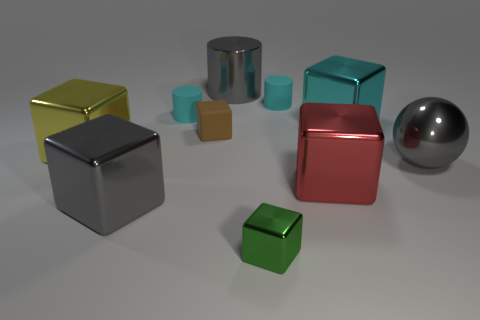Subtract all brown blocks. How many blocks are left? 5 Subtract all large gray cubes. How many cubes are left? 5 Subtract all cyan blocks. Subtract all purple balls. How many blocks are left? 5 Subtract all cubes. How many objects are left? 4 Add 1 small red rubber cubes. How many small red rubber cubes exist? 1 Subtract 0 yellow balls. How many objects are left? 10 Subtract all brown matte blocks. Subtract all gray spheres. How many objects are left? 8 Add 7 cyan cylinders. How many cyan cylinders are left? 9 